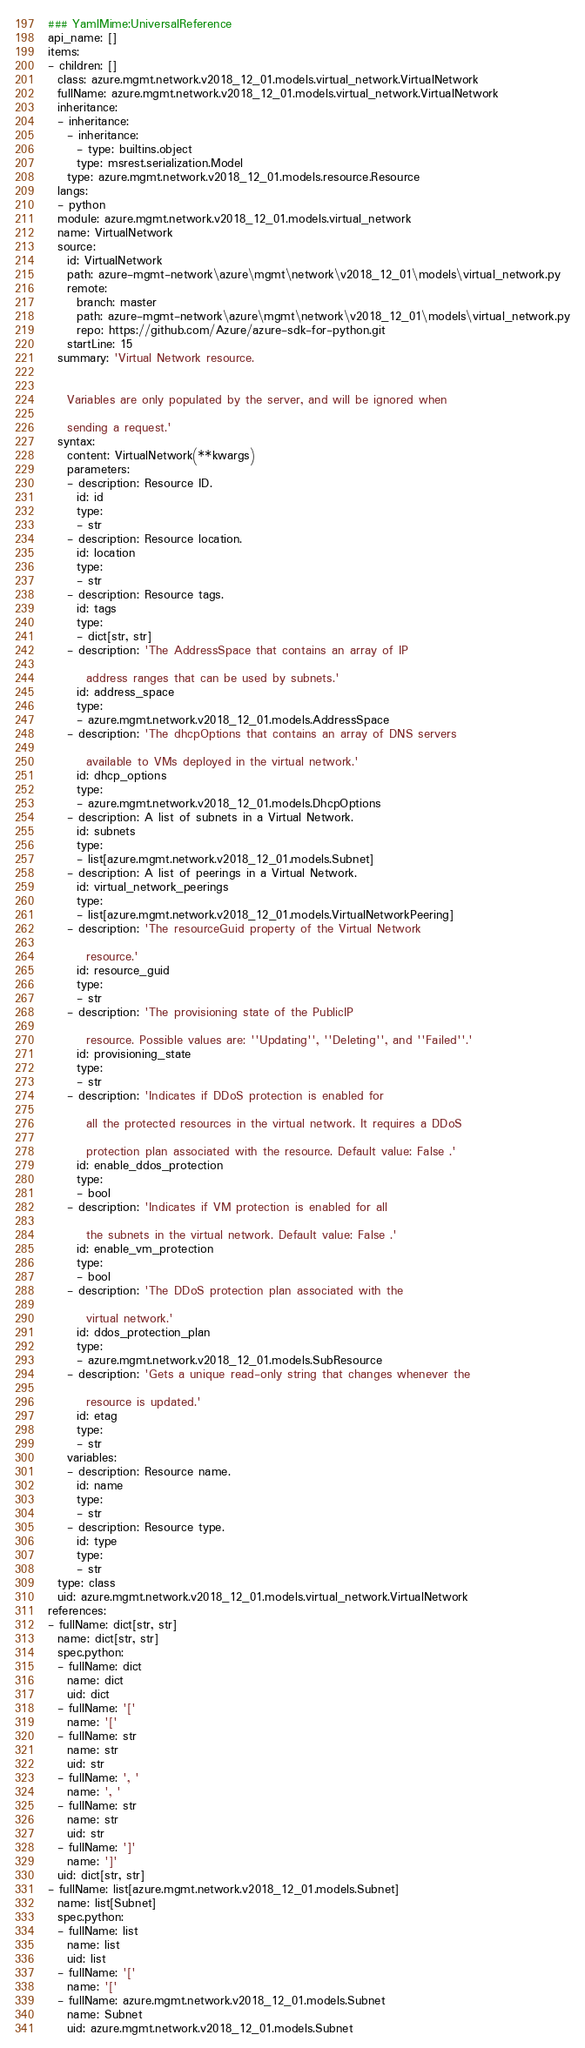Convert code to text. <code><loc_0><loc_0><loc_500><loc_500><_YAML_>### YamlMime:UniversalReference
api_name: []
items:
- children: []
  class: azure.mgmt.network.v2018_12_01.models.virtual_network.VirtualNetwork
  fullName: azure.mgmt.network.v2018_12_01.models.virtual_network.VirtualNetwork
  inheritance:
  - inheritance:
    - inheritance:
      - type: builtins.object
      type: msrest.serialization.Model
    type: azure.mgmt.network.v2018_12_01.models.resource.Resource
  langs:
  - python
  module: azure.mgmt.network.v2018_12_01.models.virtual_network
  name: VirtualNetwork
  source:
    id: VirtualNetwork
    path: azure-mgmt-network\azure\mgmt\network\v2018_12_01\models\virtual_network.py
    remote:
      branch: master
      path: azure-mgmt-network\azure\mgmt\network\v2018_12_01\models\virtual_network.py
      repo: https://github.com/Azure/azure-sdk-for-python.git
    startLine: 15
  summary: 'Virtual Network resource.


    Variables are only populated by the server, and will be ignored when

    sending a request.'
  syntax:
    content: VirtualNetwork(**kwargs)
    parameters:
    - description: Resource ID.
      id: id
      type:
      - str
    - description: Resource location.
      id: location
      type:
      - str
    - description: Resource tags.
      id: tags
      type:
      - dict[str, str]
    - description: 'The AddressSpace that contains an array of IP

        address ranges that can be used by subnets.'
      id: address_space
      type:
      - azure.mgmt.network.v2018_12_01.models.AddressSpace
    - description: 'The dhcpOptions that contains an array of DNS servers

        available to VMs deployed in the virtual network.'
      id: dhcp_options
      type:
      - azure.mgmt.network.v2018_12_01.models.DhcpOptions
    - description: A list of subnets in a Virtual Network.
      id: subnets
      type:
      - list[azure.mgmt.network.v2018_12_01.models.Subnet]
    - description: A list of peerings in a Virtual Network.
      id: virtual_network_peerings
      type:
      - list[azure.mgmt.network.v2018_12_01.models.VirtualNetworkPeering]
    - description: 'The resourceGuid property of the Virtual Network

        resource.'
      id: resource_guid
      type:
      - str
    - description: 'The provisioning state of the PublicIP

        resource. Possible values are: ''Updating'', ''Deleting'', and ''Failed''.'
      id: provisioning_state
      type:
      - str
    - description: 'Indicates if DDoS protection is enabled for

        all the protected resources in the virtual network. It requires a DDoS

        protection plan associated with the resource. Default value: False .'
      id: enable_ddos_protection
      type:
      - bool
    - description: 'Indicates if VM protection is enabled for all

        the subnets in the virtual network. Default value: False .'
      id: enable_vm_protection
      type:
      - bool
    - description: 'The DDoS protection plan associated with the

        virtual network.'
      id: ddos_protection_plan
      type:
      - azure.mgmt.network.v2018_12_01.models.SubResource
    - description: 'Gets a unique read-only string that changes whenever the

        resource is updated.'
      id: etag
      type:
      - str
    variables:
    - description: Resource name.
      id: name
      type:
      - str
    - description: Resource type.
      id: type
      type:
      - str
  type: class
  uid: azure.mgmt.network.v2018_12_01.models.virtual_network.VirtualNetwork
references:
- fullName: dict[str, str]
  name: dict[str, str]
  spec.python:
  - fullName: dict
    name: dict
    uid: dict
  - fullName: '['
    name: '['
  - fullName: str
    name: str
    uid: str
  - fullName: ', '
    name: ', '
  - fullName: str
    name: str
    uid: str
  - fullName: ']'
    name: ']'
  uid: dict[str, str]
- fullName: list[azure.mgmt.network.v2018_12_01.models.Subnet]
  name: list[Subnet]
  spec.python:
  - fullName: list
    name: list
    uid: list
  - fullName: '['
    name: '['
  - fullName: azure.mgmt.network.v2018_12_01.models.Subnet
    name: Subnet
    uid: azure.mgmt.network.v2018_12_01.models.Subnet</code> 